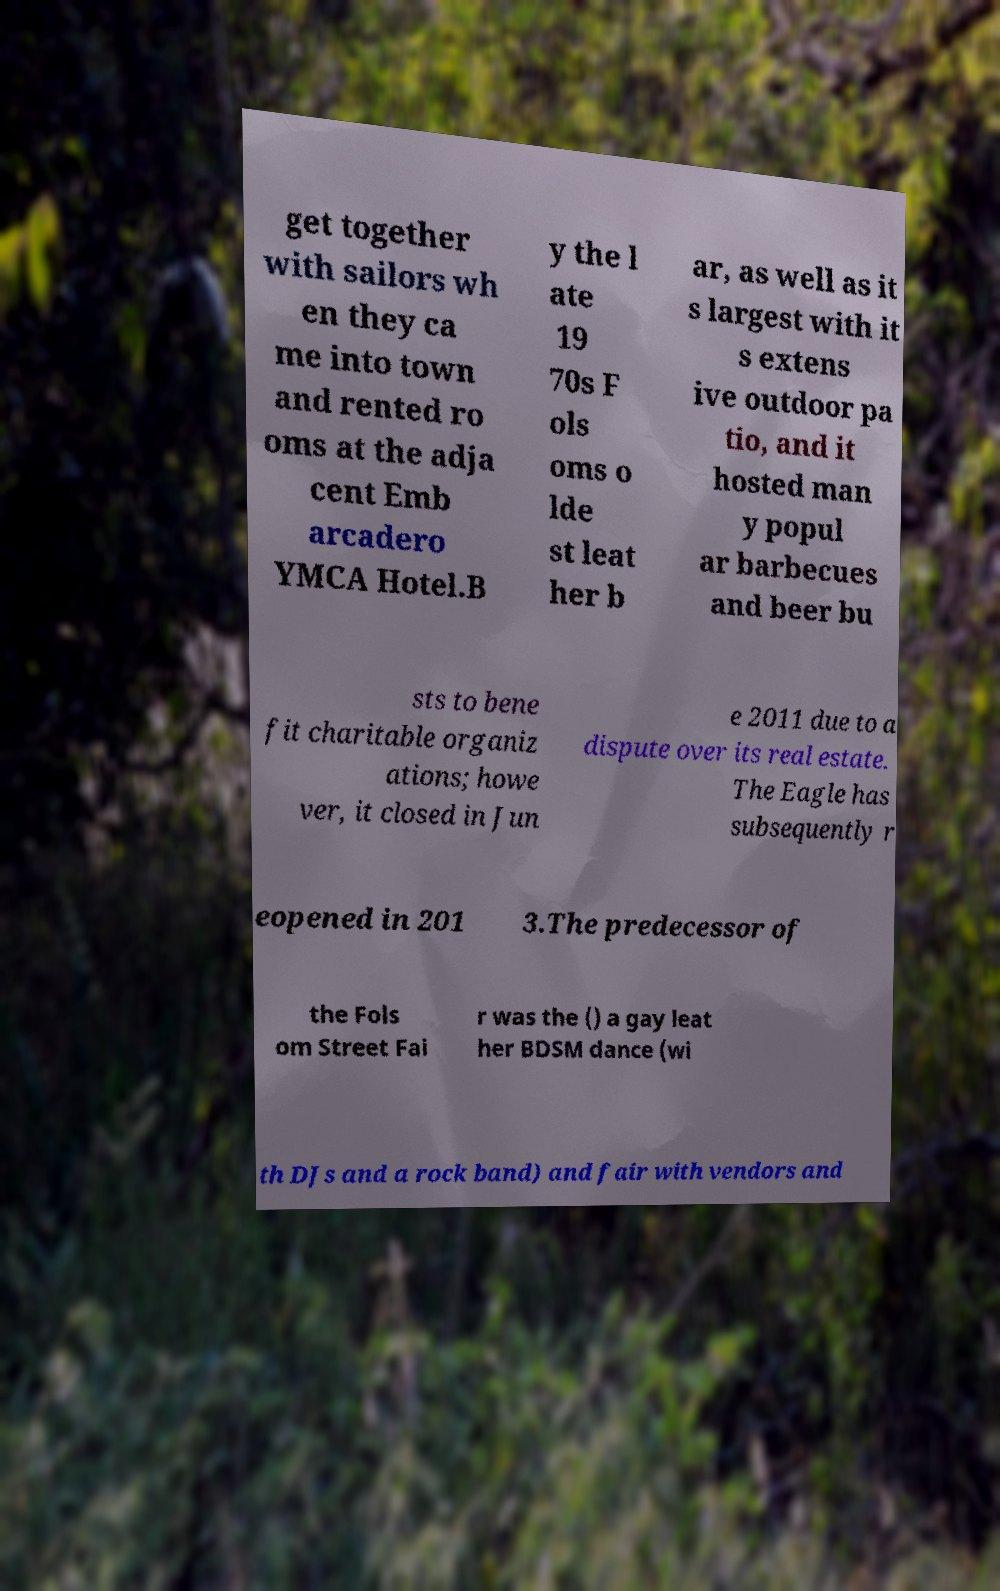Please identify and transcribe the text found in this image. get together with sailors wh en they ca me into town and rented ro oms at the adja cent Emb arcadero YMCA Hotel.B y the l ate 19 70s F ols oms o lde st leat her b ar, as well as it s largest with it s extens ive outdoor pa tio, and it hosted man y popul ar barbecues and beer bu sts to bene fit charitable organiz ations; howe ver, it closed in Jun e 2011 due to a dispute over its real estate. The Eagle has subsequently r eopened in 201 3.The predecessor of the Fols om Street Fai r was the () a gay leat her BDSM dance (wi th DJs and a rock band) and fair with vendors and 